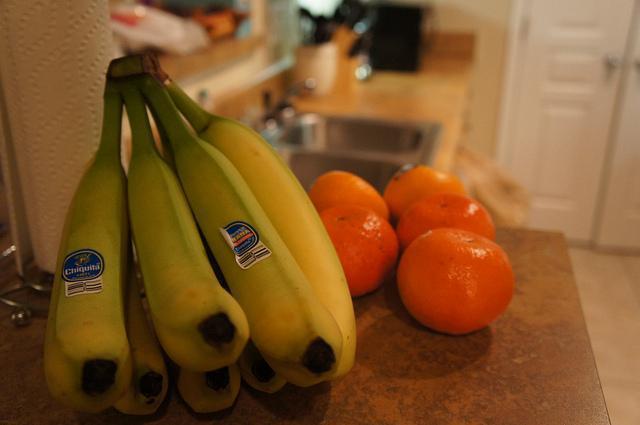What is next to the banana?
Make your selection from the four choices given to correctly answer the question.
Options: Fork, scimitar, machete, orange. Orange. 